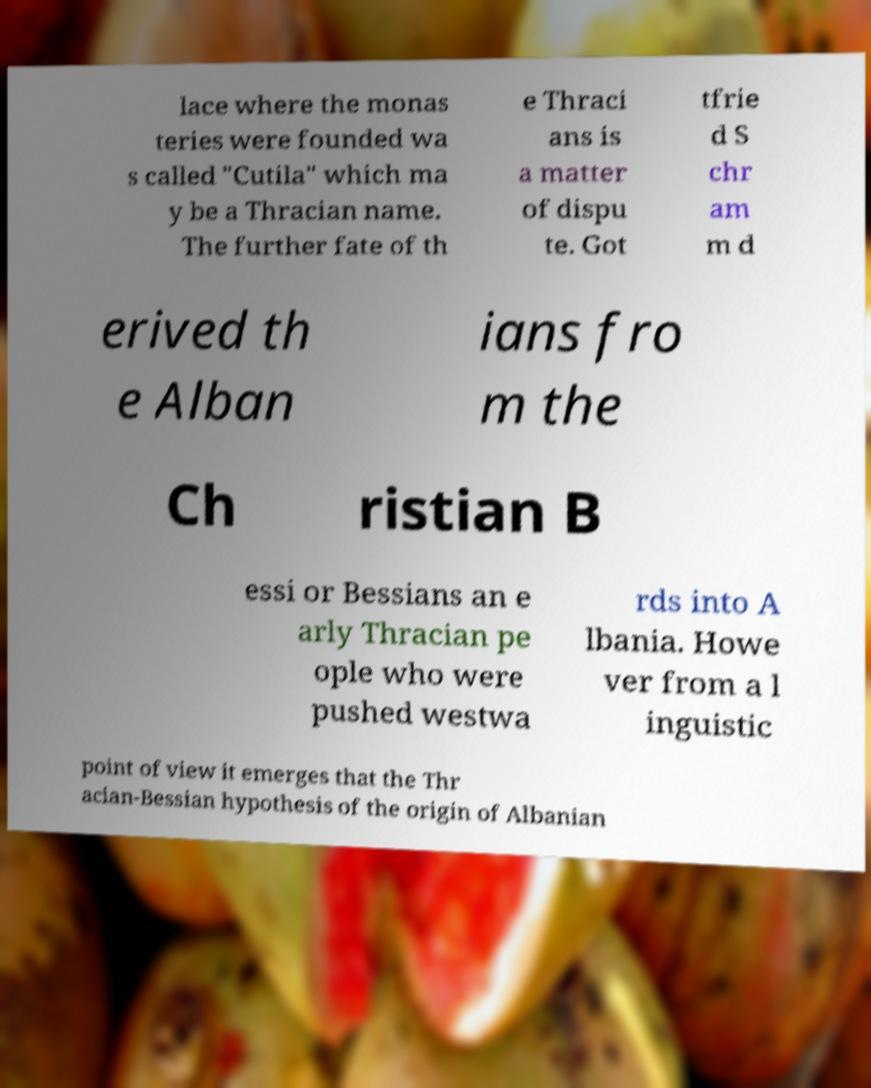Please read and relay the text visible in this image. What does it say? lace where the monas teries were founded wa s called "Cutila" which ma y be a Thracian name. The further fate of th e Thraci ans is a matter of dispu te. Got tfrie d S chr am m d erived th e Alban ians fro m the Ch ristian B essi or Bessians an e arly Thracian pe ople who were pushed westwa rds into A lbania. Howe ver from a l inguistic point of view it emerges that the Thr acian-Bessian hypothesis of the origin of Albanian 